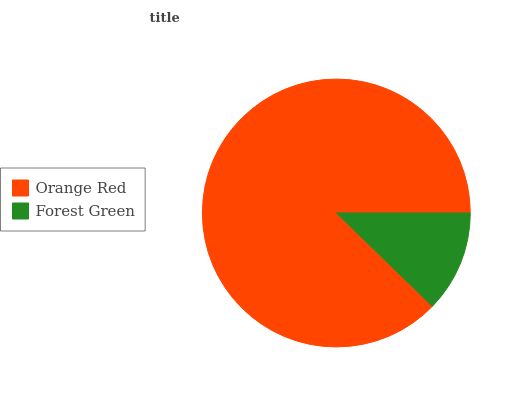Is Forest Green the minimum?
Answer yes or no. Yes. Is Orange Red the maximum?
Answer yes or no. Yes. Is Forest Green the maximum?
Answer yes or no. No. Is Orange Red greater than Forest Green?
Answer yes or no. Yes. Is Forest Green less than Orange Red?
Answer yes or no. Yes. Is Forest Green greater than Orange Red?
Answer yes or no. No. Is Orange Red less than Forest Green?
Answer yes or no. No. Is Orange Red the high median?
Answer yes or no. Yes. Is Forest Green the low median?
Answer yes or no. Yes. Is Forest Green the high median?
Answer yes or no. No. Is Orange Red the low median?
Answer yes or no. No. 